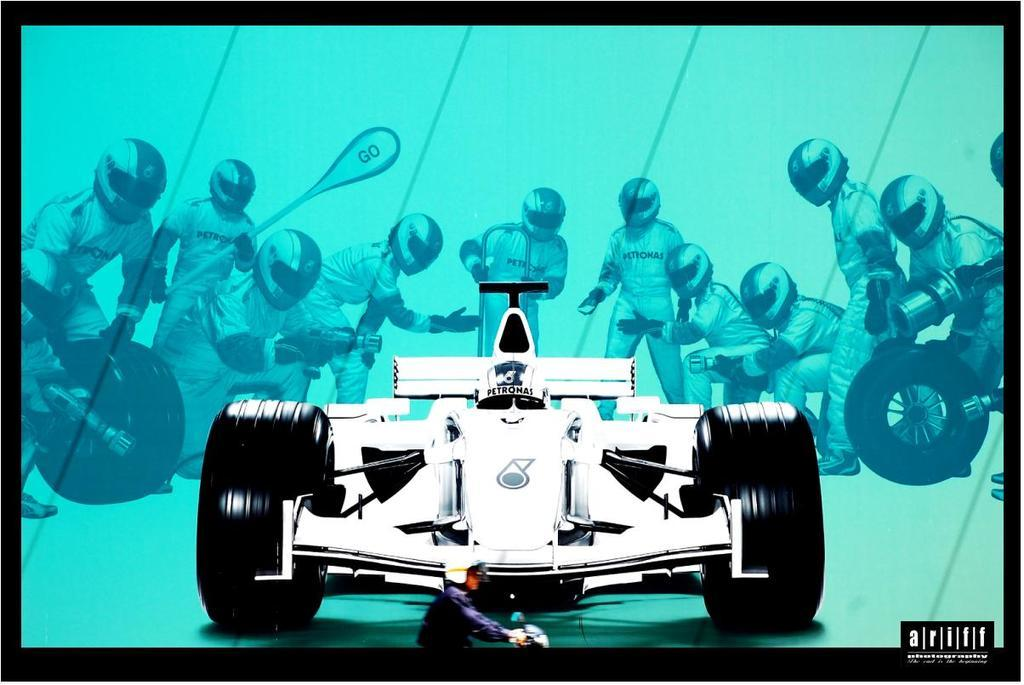What type of image is being described? The image is an animation. What is the main subject in the animation? There is a car in the middle of the image. What are the workers doing around the car? The workers are holding tools such as tires, rods, and fitters. How many girls are present in the image? There is no mention of girls in the provided facts, so it cannot be determined from the image. 